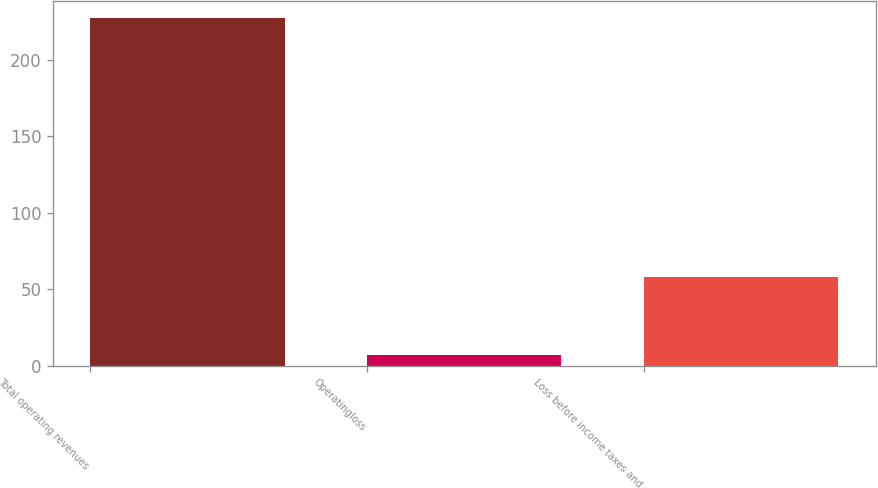Convert chart. <chart><loc_0><loc_0><loc_500><loc_500><bar_chart><fcel>Total operating revenues<fcel>Operatingloss<fcel>Loss before income taxes and<nl><fcel>227<fcel>7<fcel>58<nl></chart> 